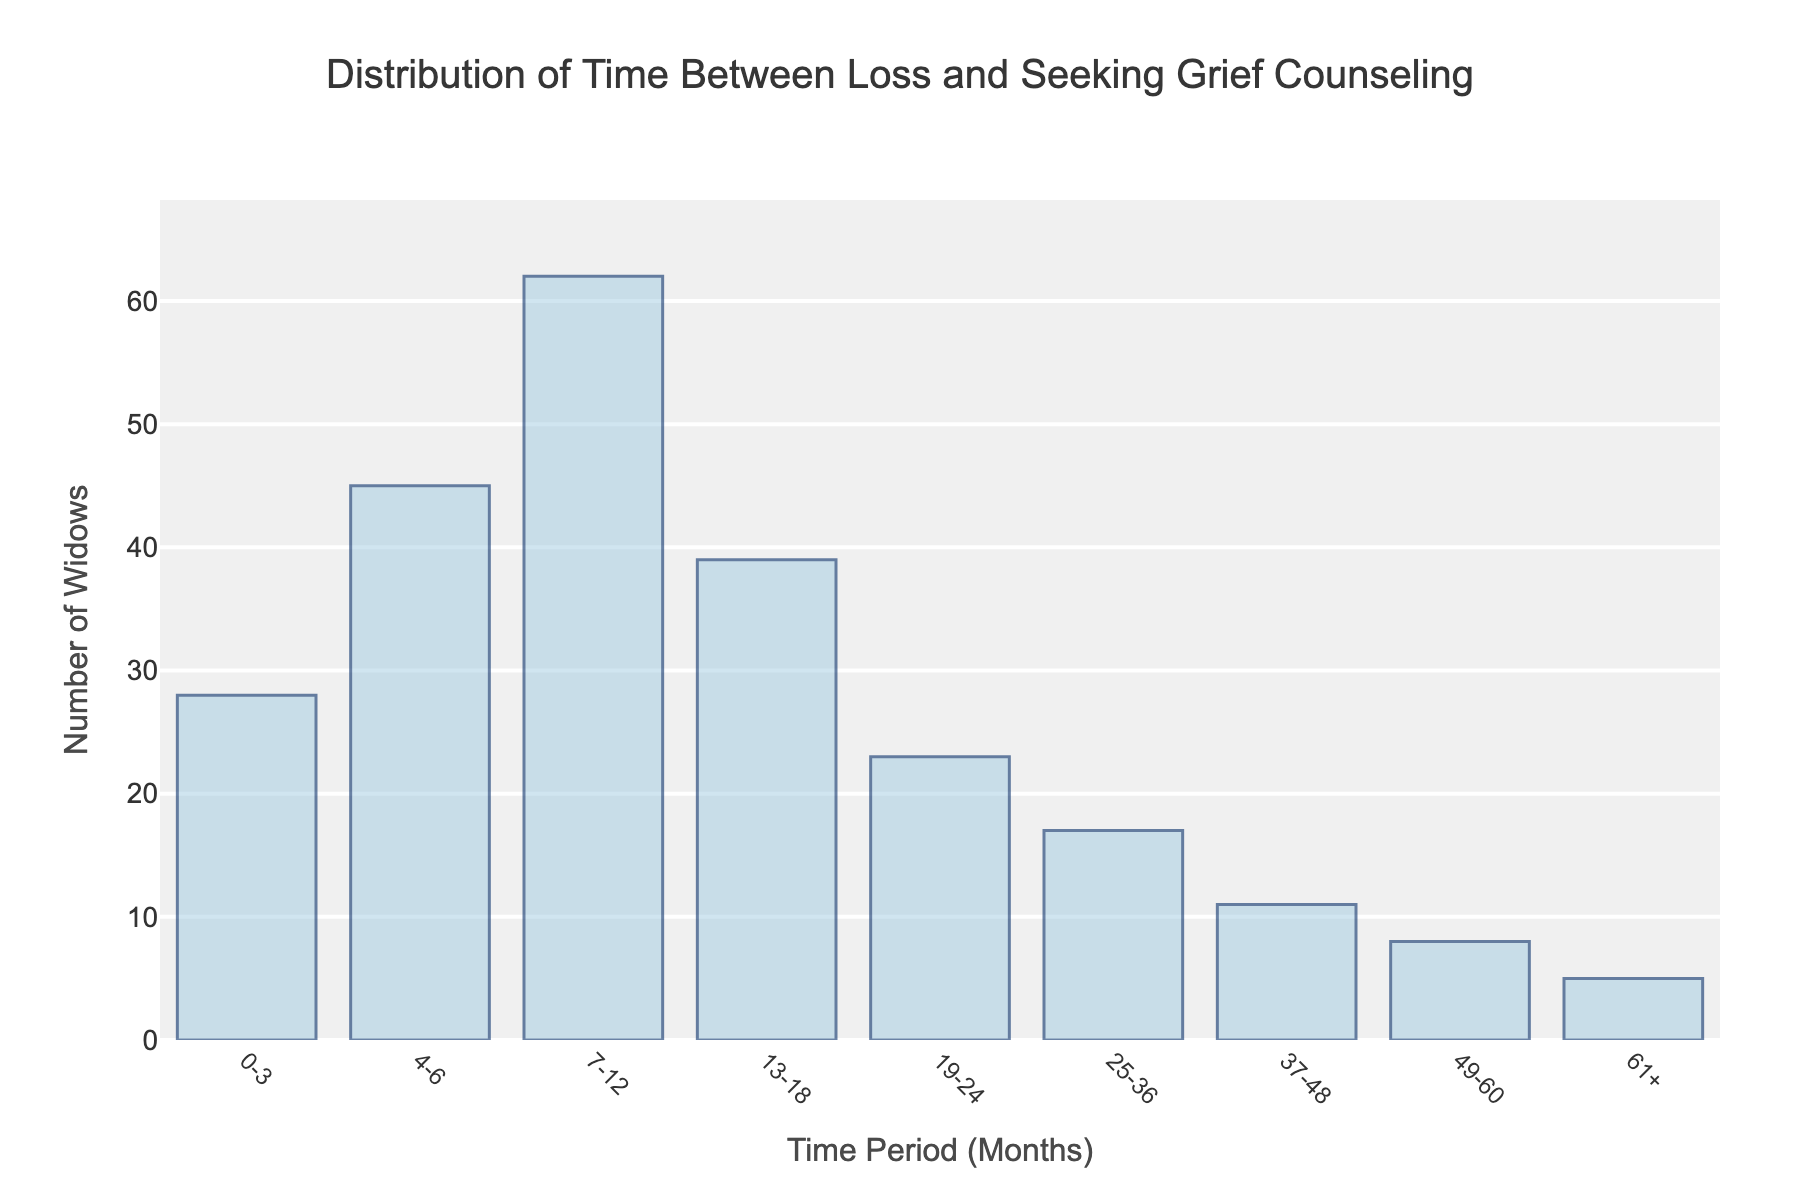What is the title of the histogram? The title of the histogram is displayed at the top of the figure. It provides a summary of what the chart is showing.
Answer: Distribution of Time Between Loss and Seeking Grief Counseling What is the time period with the highest number of widows seeking grief counseling? The highest bar in the histogram indicates the time period with the most number of widows.
Answer: 7-12 months How many widows sought counseling within 13-18 months after their loss? By looking at the height of the bar corresponding to the 13-18 months time period, we can determine the number of widows.
Answer: 39 Which time period had the fewest number of widows seeking counseling? The shortest bar in the histogram shows the time period with the fewest widows.
Answer: 61+ months What is the total number of widows who sought professional grief counseling from 0 to 6 months? Add the number of widows in the 0-3 and 4-6 month periods.
Answer: 28 + 45 = 73 Compare the number of widows who sought counseling in the 7-12 month period versus the 19-24 month period. Look at the heights of the bars for the 7-12 and 19-24 month periods and compare them.
Answer: 62 is greater than 23 What is the sum of widows who sought counseling in the time periods of 37-48 months and 49-60 months? Add the number of widows for 37-48 and 49-60 month periods.
Answer: 11 + 8 = 19 How does the number of widows seeking counseling in the first 12 months compare to those in the 13-24 months? Add the numbers for 0-3, 4-6, and 7-12 months, and compare this sum to the sum of those in the 13-18 and 19-24 month periods.
Answer: (28+45+62) is greater than (39+23) What is the average number of widows seeking counseling in the time periods of 0-12 months? Add the widows from 0-3, 4-6, and 7-12 months and divide by the number of time periods (3).
Answer: (28+45+62) / 3 = 135 / 3 = 45 What does the histogram tell us about the overall trend in the number of widows seeking counseling over time? Examine the height of the bars from left to right to observe the trend.
Answer: The number decreases over time after peaking in the 7-12 month period 